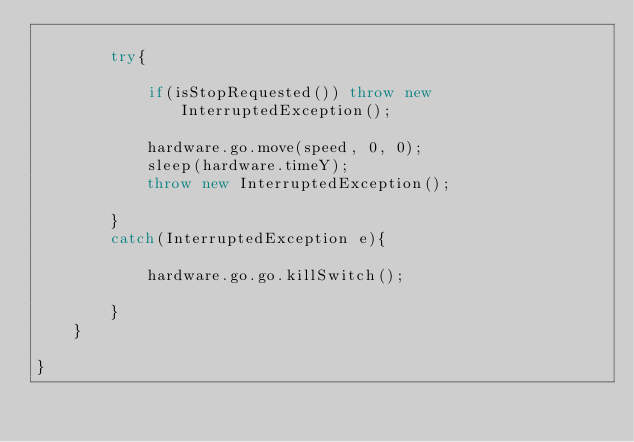Convert code to text. <code><loc_0><loc_0><loc_500><loc_500><_Java_>
        try{

            if(isStopRequested()) throw new InterruptedException();

            hardware.go.move(speed, 0, 0);
            sleep(hardware.timeY);
            throw new InterruptedException();

        }
        catch(InterruptedException e){

            hardware.go.go.killSwitch();

        }
    }

}
</code> 